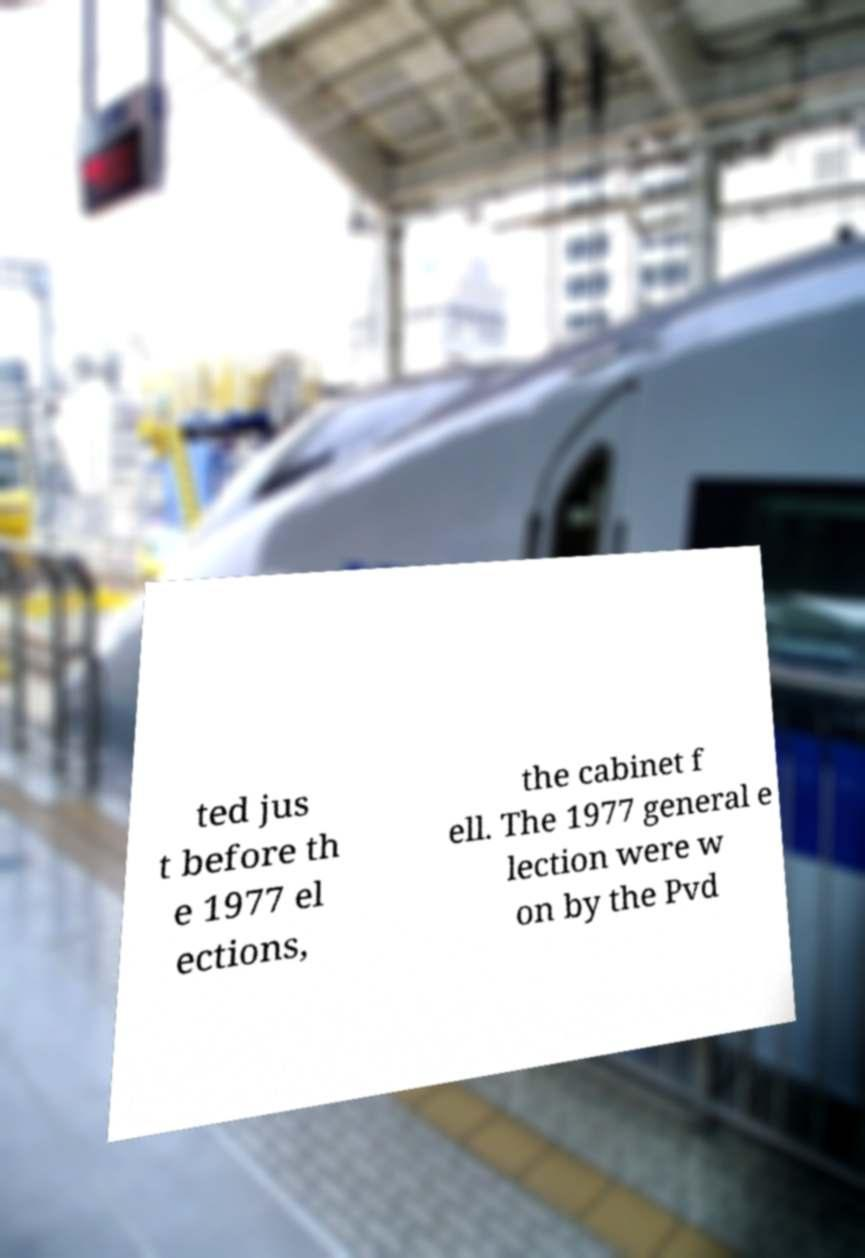Can you read and provide the text displayed in the image?This photo seems to have some interesting text. Can you extract and type it out for me? ted jus t before th e 1977 el ections, the cabinet f ell. The 1977 general e lection were w on by the Pvd 